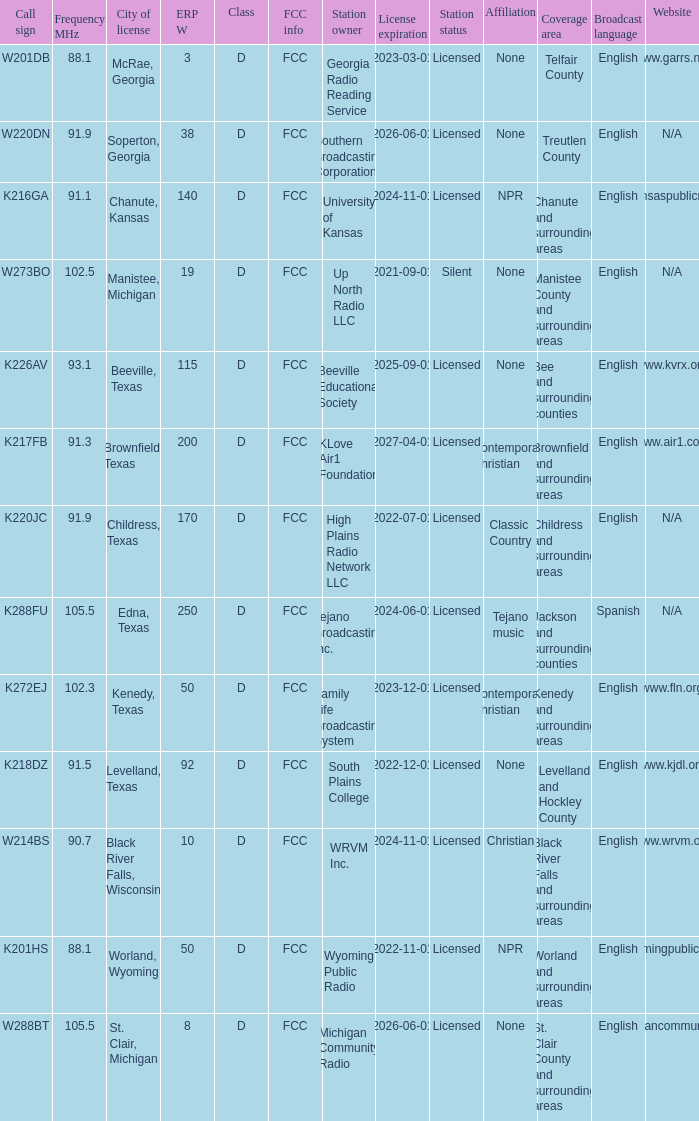Would you mind parsing the complete table? {'header': ['Call sign', 'Frequency MHz', 'City of license', 'ERP W', 'Class', 'FCC info', 'Station owner', 'License expiration', 'Station status', 'Affiliation', 'Coverage area', 'Broadcast language', 'Website'], 'rows': [['W201DB', '88.1', 'McRae, Georgia', '3', 'D', 'FCC', 'Georgia Radio Reading Service', '2023-03-01', 'Licensed', 'None', 'Telfair County', 'English', 'www.garrs.net'], ['W220DN', '91.9', 'Soperton, Georgia', '38', 'D', 'FCC', 'Southern Broadcasting Corporation', '2026-06-01', 'Licensed', 'None', 'Treutlen County', 'English', 'N/A'], ['K216GA', '91.1', 'Chanute, Kansas', '140', 'D', 'FCC', 'University of Kansas', '2024-11-01', 'Licensed', 'NPR', 'Chanute and surrounding areas', 'English', 'www.kansaspublicradio.org'], ['W273BO', '102.5', 'Manistee, Michigan', '19', 'D', 'FCC', 'Up North Radio LLC', '2021-09-01', 'Silent', 'None', 'Manistee County and surrounding areas', 'English', 'N/A'], ['K226AV', '93.1', 'Beeville, Texas', '115', 'D', 'FCC', 'Beeville Educational Society', '2025-09-01', 'Licensed', 'None', 'Bee and surrounding counties', 'English', 'www.kvrx.org'], ['K217FB', '91.3', 'Brownfield, Texas', '200', 'D', 'FCC', 'KLove Air1 Foundation', '2027-04-01', 'Licensed', 'Contemporary Christian', 'Brownfield and surrounding areas', 'English', 'www.air1.com'], ['K220JC', '91.9', 'Childress, Texas', '170', 'D', 'FCC', 'High Plains Radio Network LLC', '2022-07-01', 'Licensed', 'Classic Country', 'Childress and surrounding areas', 'English', 'N/A'], ['K288FU', '105.5', 'Edna, Texas', '250', 'D', 'FCC', 'Tejano Broadcasting Inc.', '2024-06-01', 'Licensed', 'Tejano music', 'Jackson and surrounding counties', 'Spanish', 'N/A'], ['K272EJ', '102.3', 'Kenedy, Texas', '50', 'D', 'FCC', 'Family Life Broadcasting System', '2023-12-01', 'Licensed', 'Contemporary Christian', 'Kenedy and surrounding areas', 'English', 'www.fln.org'], ['K218DZ', '91.5', 'Levelland, Texas', '92', 'D', 'FCC', 'South Plains College', '2022-12-01', 'Licensed', 'None', 'Levelland and Hockley County', 'English', 'www.kjdl.org'], ['W214BS', '90.7', 'Black River Falls, Wisconsin', '10', 'D', 'FCC', 'WRVM Inc.', '2024-11-01', 'Licensed', 'Christian', 'Black River Falls and surrounding areas', 'English', 'www.wrvm.org'], ['K201HS', '88.1', 'Worland, Wyoming', '50', 'D', 'FCC', 'Wyoming Public Radio', '2022-11-01', 'Licensed', 'NPR', 'Worland and surrounding areas', 'English', 'www.wyomingpublicmedia.org'], ['W288BT', '105.5', 'St. Clair, Michigan', '8', 'D', 'FCC', 'Michigan Community Radio', '2026-06-01', 'Licensed', 'None', 'St. Clair County and surrounding areas', 'English', 'www.michigancommunityradio.org']]} What is City of License, when Frequency MHz is less than 102.5? McRae, Georgia, Soperton, Georgia, Chanute, Kansas, Beeville, Texas, Brownfield, Texas, Childress, Texas, Kenedy, Texas, Levelland, Texas, Black River Falls, Wisconsin, Worland, Wyoming. 